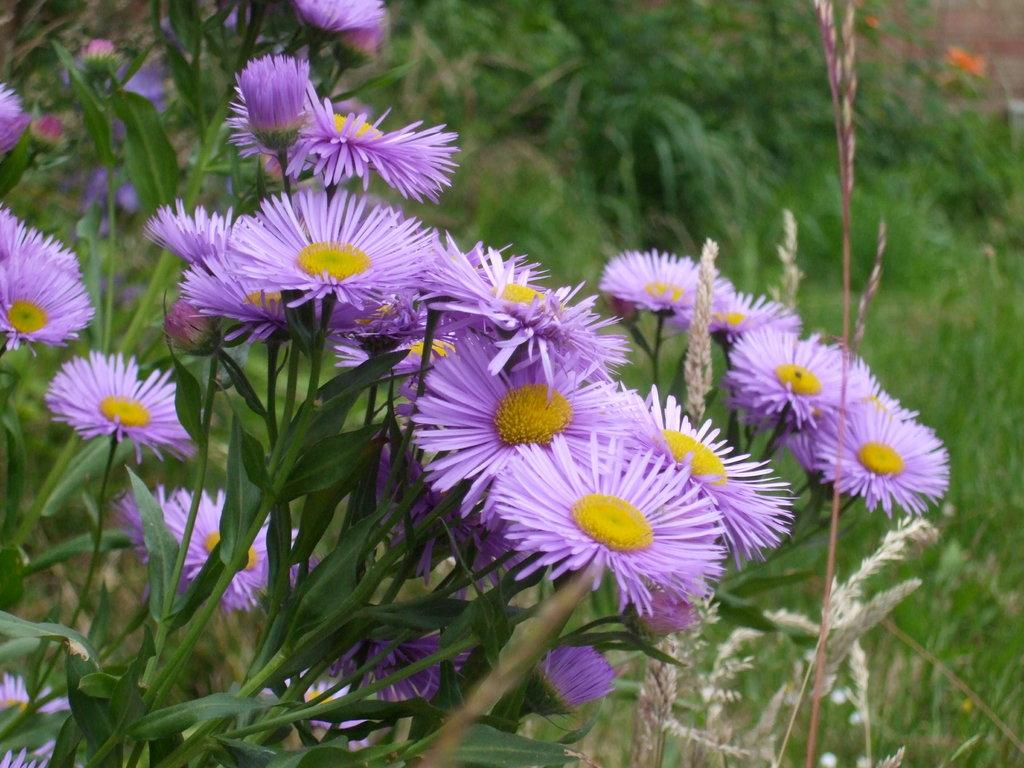What type of living organisms can be seen in the image? The image contains plants and flowers. What color are the flowers in the image? The flowers are violet in color. What is the center of the flowers like? The flowers have a yellow center. What type of grain can be seen growing among the flowers in the image? There is no grain present in the image; it only contains flowers and plants. 